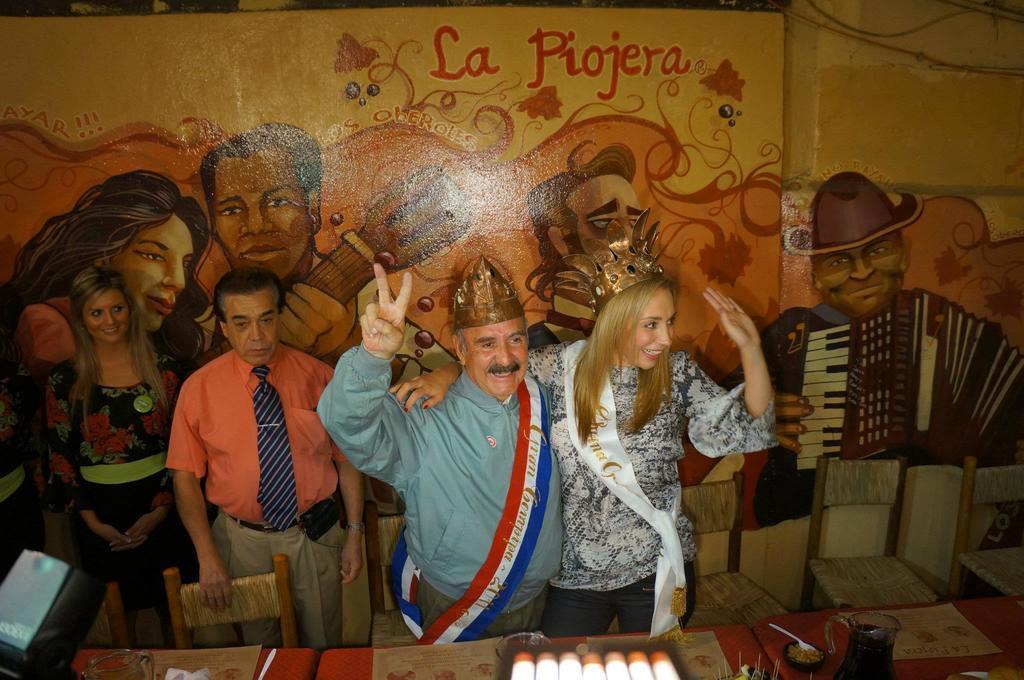Describe this image in one or two sentences. In this picture, we see two men and two women are standing. The man and the woman are wearing the crowns on their hand and they are smiling. In front of them, we see a table on which glass jar, a bowl, spoon, glass and some other objects are placed. In the left bottom, we see an object in grey and black color. Beside that, we see a chair. Behind them, we see many chairs. In the background, we see a wall which is painted with yellow and orange color. We even see the paintings of the man and the woman. 